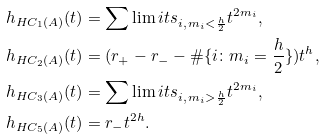<formula> <loc_0><loc_0><loc_500><loc_500>h _ { H C _ { 1 } ( A ) } ( t ) & = \sum \lim i t s _ { i , \, m _ { i } < \frac { h } { 2 } } t ^ { 2 m _ { i } } , \\ h _ { H C _ { 2 } ( A ) } ( t ) & = ( r _ { + } - r _ { - } - \# \{ i \colon m _ { i } = \frac { h } { 2 } \} ) t ^ { h } , \\ h _ { H C _ { 3 } ( A ) } ( t ) & = \sum \lim i t s _ { i , \, m _ { i } > \frac { h } { 2 } } t ^ { 2 m _ { i } } , \\ h _ { H C _ { 5 } ( A ) } ( t ) & = r _ { - } t ^ { 2 h } . \\</formula> 